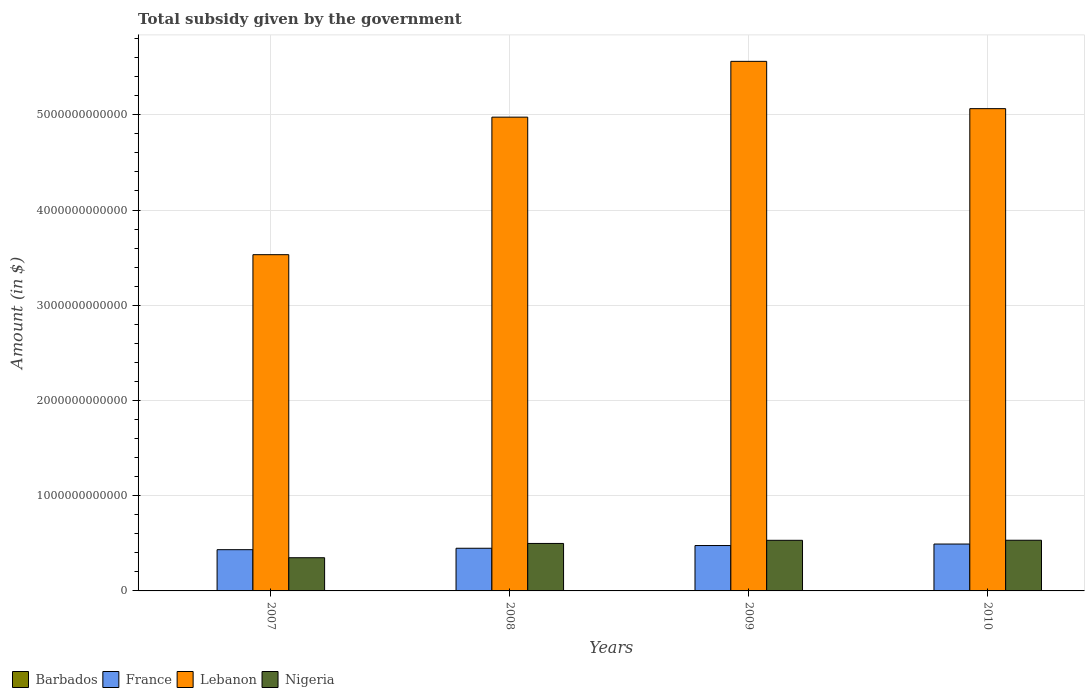How many different coloured bars are there?
Offer a very short reply. 4. Are the number of bars on each tick of the X-axis equal?
Your response must be concise. Yes. How many bars are there on the 3rd tick from the left?
Offer a terse response. 4. How many bars are there on the 2nd tick from the right?
Your response must be concise. 4. What is the total revenue collected by the government in Lebanon in 2009?
Your response must be concise. 5.56e+12. Across all years, what is the maximum total revenue collected by the government in France?
Your response must be concise. 4.92e+11. Across all years, what is the minimum total revenue collected by the government in Barbados?
Offer a very short reply. 1.14e+09. In which year was the total revenue collected by the government in Nigeria maximum?
Make the answer very short. 2010. In which year was the total revenue collected by the government in Barbados minimum?
Ensure brevity in your answer.  2007. What is the total total revenue collected by the government in Nigeria in the graph?
Provide a succinct answer. 1.91e+12. What is the difference between the total revenue collected by the government in France in 2007 and that in 2009?
Your response must be concise. -4.34e+1. What is the difference between the total revenue collected by the government in France in 2008 and the total revenue collected by the government in Nigeria in 2010?
Make the answer very short. -8.43e+1. What is the average total revenue collected by the government in Barbados per year?
Keep it short and to the point. 1.22e+09. In the year 2009, what is the difference between the total revenue collected by the government in France and total revenue collected by the government in Barbados?
Offer a terse response. 4.75e+11. In how many years, is the total revenue collected by the government in Barbados greater than 3800000000000 $?
Make the answer very short. 0. What is the ratio of the total revenue collected by the government in Nigeria in 2009 to that in 2010?
Ensure brevity in your answer.  1. What is the difference between the highest and the second highest total revenue collected by the government in Barbados?
Give a very brief answer. 1.23e+06. What is the difference between the highest and the lowest total revenue collected by the government in France?
Make the answer very short. 5.92e+1. In how many years, is the total revenue collected by the government in Barbados greater than the average total revenue collected by the government in Barbados taken over all years?
Keep it short and to the point. 3. Is the sum of the total revenue collected by the government in Nigeria in 2007 and 2008 greater than the maximum total revenue collected by the government in Lebanon across all years?
Provide a short and direct response. No. What does the 3rd bar from the left in 2010 represents?
Ensure brevity in your answer.  Lebanon. What does the 2nd bar from the right in 2009 represents?
Offer a very short reply. Lebanon. Is it the case that in every year, the sum of the total revenue collected by the government in France and total revenue collected by the government in Barbados is greater than the total revenue collected by the government in Nigeria?
Your answer should be compact. No. What is the difference between two consecutive major ticks on the Y-axis?
Offer a terse response. 1.00e+12. Are the values on the major ticks of Y-axis written in scientific E-notation?
Give a very brief answer. No. Where does the legend appear in the graph?
Offer a terse response. Bottom left. How many legend labels are there?
Make the answer very short. 4. How are the legend labels stacked?
Your response must be concise. Horizontal. What is the title of the graph?
Ensure brevity in your answer.  Total subsidy given by the government. Does "Latin America(all income levels)" appear as one of the legend labels in the graph?
Give a very brief answer. No. What is the label or title of the Y-axis?
Offer a terse response. Amount (in $). What is the Amount (in $) of Barbados in 2007?
Offer a terse response. 1.14e+09. What is the Amount (in $) of France in 2007?
Offer a very short reply. 4.33e+11. What is the Amount (in $) in Lebanon in 2007?
Your answer should be compact. 3.53e+12. What is the Amount (in $) in Nigeria in 2007?
Your answer should be compact. 3.49e+11. What is the Amount (in $) in Barbados in 2008?
Give a very brief answer. 1.25e+09. What is the Amount (in $) of France in 2008?
Offer a terse response. 4.48e+11. What is the Amount (in $) in Lebanon in 2008?
Your answer should be very brief. 4.98e+12. What is the Amount (in $) in Nigeria in 2008?
Give a very brief answer. 4.99e+11. What is the Amount (in $) of Barbados in 2009?
Keep it short and to the point. 1.23e+09. What is the Amount (in $) of France in 2009?
Offer a terse response. 4.77e+11. What is the Amount (in $) of Lebanon in 2009?
Offer a very short reply. 5.56e+12. What is the Amount (in $) in Nigeria in 2009?
Your answer should be compact. 5.32e+11. What is the Amount (in $) in Barbados in 2010?
Give a very brief answer. 1.25e+09. What is the Amount (in $) in France in 2010?
Provide a short and direct response. 4.92e+11. What is the Amount (in $) of Lebanon in 2010?
Your answer should be compact. 5.06e+12. What is the Amount (in $) in Nigeria in 2010?
Keep it short and to the point. 5.32e+11. Across all years, what is the maximum Amount (in $) of Barbados?
Provide a short and direct response. 1.25e+09. Across all years, what is the maximum Amount (in $) of France?
Give a very brief answer. 4.92e+11. Across all years, what is the maximum Amount (in $) in Lebanon?
Keep it short and to the point. 5.56e+12. Across all years, what is the maximum Amount (in $) in Nigeria?
Keep it short and to the point. 5.32e+11. Across all years, what is the minimum Amount (in $) in Barbados?
Give a very brief answer. 1.14e+09. Across all years, what is the minimum Amount (in $) of France?
Your response must be concise. 4.33e+11. Across all years, what is the minimum Amount (in $) in Lebanon?
Offer a very short reply. 3.53e+12. Across all years, what is the minimum Amount (in $) in Nigeria?
Provide a succinct answer. 3.49e+11. What is the total Amount (in $) in Barbados in the graph?
Ensure brevity in your answer.  4.87e+09. What is the total Amount (in $) of France in the graph?
Keep it short and to the point. 1.85e+12. What is the total Amount (in $) in Lebanon in the graph?
Offer a terse response. 1.91e+13. What is the total Amount (in $) in Nigeria in the graph?
Give a very brief answer. 1.91e+12. What is the difference between the Amount (in $) in Barbados in 2007 and that in 2008?
Keep it short and to the point. -1.06e+08. What is the difference between the Amount (in $) of France in 2007 and that in 2008?
Keep it short and to the point. -1.49e+1. What is the difference between the Amount (in $) of Lebanon in 2007 and that in 2008?
Give a very brief answer. -1.44e+12. What is the difference between the Amount (in $) of Nigeria in 2007 and that in 2008?
Keep it short and to the point. -1.50e+11. What is the difference between the Amount (in $) of Barbados in 2007 and that in 2009?
Your answer should be compact. -8.42e+07. What is the difference between the Amount (in $) in France in 2007 and that in 2009?
Give a very brief answer. -4.34e+1. What is the difference between the Amount (in $) in Lebanon in 2007 and that in 2009?
Give a very brief answer. -2.03e+12. What is the difference between the Amount (in $) in Nigeria in 2007 and that in 2009?
Provide a succinct answer. -1.83e+11. What is the difference between the Amount (in $) in Barbados in 2007 and that in 2010?
Make the answer very short. -1.07e+08. What is the difference between the Amount (in $) in France in 2007 and that in 2010?
Provide a succinct answer. -5.92e+1. What is the difference between the Amount (in $) of Lebanon in 2007 and that in 2010?
Provide a succinct answer. -1.53e+12. What is the difference between the Amount (in $) of Nigeria in 2007 and that in 2010?
Your answer should be compact. -1.84e+11. What is the difference between the Amount (in $) of Barbados in 2008 and that in 2009?
Your response must be concise. 2.16e+07. What is the difference between the Amount (in $) of France in 2008 and that in 2009?
Your answer should be compact. -2.86e+1. What is the difference between the Amount (in $) of Lebanon in 2008 and that in 2009?
Your answer should be very brief. -5.86e+11. What is the difference between the Amount (in $) of Nigeria in 2008 and that in 2009?
Provide a succinct answer. -3.30e+1. What is the difference between the Amount (in $) in Barbados in 2008 and that in 2010?
Keep it short and to the point. -1.23e+06. What is the difference between the Amount (in $) in France in 2008 and that in 2010?
Provide a succinct answer. -4.43e+1. What is the difference between the Amount (in $) in Lebanon in 2008 and that in 2010?
Give a very brief answer. -8.91e+1. What is the difference between the Amount (in $) of Nigeria in 2008 and that in 2010?
Your response must be concise. -3.37e+1. What is the difference between the Amount (in $) of Barbados in 2009 and that in 2010?
Provide a succinct answer. -2.28e+07. What is the difference between the Amount (in $) of France in 2009 and that in 2010?
Ensure brevity in your answer.  -1.57e+1. What is the difference between the Amount (in $) in Lebanon in 2009 and that in 2010?
Provide a short and direct response. 4.97e+11. What is the difference between the Amount (in $) of Nigeria in 2009 and that in 2010?
Your answer should be very brief. -7.00e+08. What is the difference between the Amount (in $) of Barbados in 2007 and the Amount (in $) of France in 2008?
Give a very brief answer. -4.47e+11. What is the difference between the Amount (in $) of Barbados in 2007 and the Amount (in $) of Lebanon in 2008?
Offer a terse response. -4.97e+12. What is the difference between the Amount (in $) in Barbados in 2007 and the Amount (in $) in Nigeria in 2008?
Ensure brevity in your answer.  -4.97e+11. What is the difference between the Amount (in $) in France in 2007 and the Amount (in $) in Lebanon in 2008?
Offer a very short reply. -4.54e+12. What is the difference between the Amount (in $) of France in 2007 and the Amount (in $) of Nigeria in 2008?
Offer a terse response. -6.55e+1. What is the difference between the Amount (in $) of Lebanon in 2007 and the Amount (in $) of Nigeria in 2008?
Keep it short and to the point. 3.03e+12. What is the difference between the Amount (in $) of Barbados in 2007 and the Amount (in $) of France in 2009?
Make the answer very short. -4.75e+11. What is the difference between the Amount (in $) of Barbados in 2007 and the Amount (in $) of Lebanon in 2009?
Your answer should be compact. -5.56e+12. What is the difference between the Amount (in $) of Barbados in 2007 and the Amount (in $) of Nigeria in 2009?
Provide a succinct answer. -5.30e+11. What is the difference between the Amount (in $) of France in 2007 and the Amount (in $) of Lebanon in 2009?
Provide a short and direct response. -5.13e+12. What is the difference between the Amount (in $) in France in 2007 and the Amount (in $) in Nigeria in 2009?
Offer a terse response. -9.85e+1. What is the difference between the Amount (in $) in Lebanon in 2007 and the Amount (in $) in Nigeria in 2009?
Your answer should be compact. 3.00e+12. What is the difference between the Amount (in $) in Barbados in 2007 and the Amount (in $) in France in 2010?
Ensure brevity in your answer.  -4.91e+11. What is the difference between the Amount (in $) in Barbados in 2007 and the Amount (in $) in Lebanon in 2010?
Provide a short and direct response. -5.06e+12. What is the difference between the Amount (in $) of Barbados in 2007 and the Amount (in $) of Nigeria in 2010?
Offer a terse response. -5.31e+11. What is the difference between the Amount (in $) of France in 2007 and the Amount (in $) of Lebanon in 2010?
Offer a terse response. -4.63e+12. What is the difference between the Amount (in $) in France in 2007 and the Amount (in $) in Nigeria in 2010?
Give a very brief answer. -9.92e+1. What is the difference between the Amount (in $) in Lebanon in 2007 and the Amount (in $) in Nigeria in 2010?
Keep it short and to the point. 3.00e+12. What is the difference between the Amount (in $) in Barbados in 2008 and the Amount (in $) in France in 2009?
Ensure brevity in your answer.  -4.75e+11. What is the difference between the Amount (in $) of Barbados in 2008 and the Amount (in $) of Lebanon in 2009?
Make the answer very short. -5.56e+12. What is the difference between the Amount (in $) in Barbados in 2008 and the Amount (in $) in Nigeria in 2009?
Your answer should be compact. -5.30e+11. What is the difference between the Amount (in $) of France in 2008 and the Amount (in $) of Lebanon in 2009?
Keep it short and to the point. -5.11e+12. What is the difference between the Amount (in $) in France in 2008 and the Amount (in $) in Nigeria in 2009?
Your answer should be compact. -8.36e+1. What is the difference between the Amount (in $) in Lebanon in 2008 and the Amount (in $) in Nigeria in 2009?
Your answer should be very brief. 4.44e+12. What is the difference between the Amount (in $) of Barbados in 2008 and the Amount (in $) of France in 2010?
Give a very brief answer. -4.91e+11. What is the difference between the Amount (in $) in Barbados in 2008 and the Amount (in $) in Lebanon in 2010?
Make the answer very short. -5.06e+12. What is the difference between the Amount (in $) in Barbados in 2008 and the Amount (in $) in Nigeria in 2010?
Keep it short and to the point. -5.31e+11. What is the difference between the Amount (in $) of France in 2008 and the Amount (in $) of Lebanon in 2010?
Keep it short and to the point. -4.62e+12. What is the difference between the Amount (in $) of France in 2008 and the Amount (in $) of Nigeria in 2010?
Your answer should be compact. -8.43e+1. What is the difference between the Amount (in $) of Lebanon in 2008 and the Amount (in $) of Nigeria in 2010?
Offer a very short reply. 4.44e+12. What is the difference between the Amount (in $) of Barbados in 2009 and the Amount (in $) of France in 2010?
Your answer should be very brief. -4.91e+11. What is the difference between the Amount (in $) in Barbados in 2009 and the Amount (in $) in Lebanon in 2010?
Your response must be concise. -5.06e+12. What is the difference between the Amount (in $) in Barbados in 2009 and the Amount (in $) in Nigeria in 2010?
Provide a short and direct response. -5.31e+11. What is the difference between the Amount (in $) in France in 2009 and the Amount (in $) in Lebanon in 2010?
Make the answer very short. -4.59e+12. What is the difference between the Amount (in $) in France in 2009 and the Amount (in $) in Nigeria in 2010?
Offer a very short reply. -5.57e+1. What is the difference between the Amount (in $) of Lebanon in 2009 and the Amount (in $) of Nigeria in 2010?
Offer a very short reply. 5.03e+12. What is the average Amount (in $) of Barbados per year?
Provide a short and direct response. 1.22e+09. What is the average Amount (in $) of France per year?
Provide a succinct answer. 4.63e+11. What is the average Amount (in $) in Lebanon per year?
Your response must be concise. 4.78e+12. What is the average Amount (in $) in Nigeria per year?
Ensure brevity in your answer.  4.78e+11. In the year 2007, what is the difference between the Amount (in $) of Barbados and Amount (in $) of France?
Offer a very short reply. -4.32e+11. In the year 2007, what is the difference between the Amount (in $) of Barbados and Amount (in $) of Lebanon?
Offer a very short reply. -3.53e+12. In the year 2007, what is the difference between the Amount (in $) of Barbados and Amount (in $) of Nigeria?
Provide a short and direct response. -3.47e+11. In the year 2007, what is the difference between the Amount (in $) in France and Amount (in $) in Lebanon?
Offer a very short reply. -3.10e+12. In the year 2007, what is the difference between the Amount (in $) of France and Amount (in $) of Nigeria?
Your response must be concise. 8.45e+1. In the year 2007, what is the difference between the Amount (in $) in Lebanon and Amount (in $) in Nigeria?
Offer a very short reply. 3.18e+12. In the year 2008, what is the difference between the Amount (in $) of Barbados and Amount (in $) of France?
Offer a very short reply. -4.47e+11. In the year 2008, what is the difference between the Amount (in $) of Barbados and Amount (in $) of Lebanon?
Provide a short and direct response. -4.97e+12. In the year 2008, what is the difference between the Amount (in $) in Barbados and Amount (in $) in Nigeria?
Make the answer very short. -4.97e+11. In the year 2008, what is the difference between the Amount (in $) in France and Amount (in $) in Lebanon?
Your answer should be very brief. -4.53e+12. In the year 2008, what is the difference between the Amount (in $) in France and Amount (in $) in Nigeria?
Keep it short and to the point. -5.06e+1. In the year 2008, what is the difference between the Amount (in $) in Lebanon and Amount (in $) in Nigeria?
Ensure brevity in your answer.  4.48e+12. In the year 2009, what is the difference between the Amount (in $) of Barbados and Amount (in $) of France?
Provide a succinct answer. -4.75e+11. In the year 2009, what is the difference between the Amount (in $) in Barbados and Amount (in $) in Lebanon?
Keep it short and to the point. -5.56e+12. In the year 2009, what is the difference between the Amount (in $) of Barbados and Amount (in $) of Nigeria?
Ensure brevity in your answer.  -5.30e+11. In the year 2009, what is the difference between the Amount (in $) in France and Amount (in $) in Lebanon?
Your answer should be very brief. -5.08e+12. In the year 2009, what is the difference between the Amount (in $) of France and Amount (in $) of Nigeria?
Keep it short and to the point. -5.50e+1. In the year 2009, what is the difference between the Amount (in $) in Lebanon and Amount (in $) in Nigeria?
Your response must be concise. 5.03e+12. In the year 2010, what is the difference between the Amount (in $) in Barbados and Amount (in $) in France?
Offer a terse response. -4.91e+11. In the year 2010, what is the difference between the Amount (in $) of Barbados and Amount (in $) of Lebanon?
Offer a terse response. -5.06e+12. In the year 2010, what is the difference between the Amount (in $) of Barbados and Amount (in $) of Nigeria?
Ensure brevity in your answer.  -5.31e+11. In the year 2010, what is the difference between the Amount (in $) in France and Amount (in $) in Lebanon?
Offer a terse response. -4.57e+12. In the year 2010, what is the difference between the Amount (in $) in France and Amount (in $) in Nigeria?
Make the answer very short. -4.00e+1. In the year 2010, what is the difference between the Amount (in $) of Lebanon and Amount (in $) of Nigeria?
Your answer should be very brief. 4.53e+12. What is the ratio of the Amount (in $) of Barbados in 2007 to that in 2008?
Provide a short and direct response. 0.92. What is the ratio of the Amount (in $) in France in 2007 to that in 2008?
Provide a short and direct response. 0.97. What is the ratio of the Amount (in $) in Lebanon in 2007 to that in 2008?
Offer a terse response. 0.71. What is the ratio of the Amount (in $) of Nigeria in 2007 to that in 2008?
Give a very brief answer. 0.7. What is the ratio of the Amount (in $) in Barbados in 2007 to that in 2009?
Provide a succinct answer. 0.93. What is the ratio of the Amount (in $) in France in 2007 to that in 2009?
Provide a short and direct response. 0.91. What is the ratio of the Amount (in $) in Lebanon in 2007 to that in 2009?
Give a very brief answer. 0.63. What is the ratio of the Amount (in $) in Nigeria in 2007 to that in 2009?
Your answer should be compact. 0.66. What is the ratio of the Amount (in $) of Barbados in 2007 to that in 2010?
Your answer should be compact. 0.91. What is the ratio of the Amount (in $) of France in 2007 to that in 2010?
Your answer should be compact. 0.88. What is the ratio of the Amount (in $) in Lebanon in 2007 to that in 2010?
Provide a short and direct response. 0.7. What is the ratio of the Amount (in $) of Nigeria in 2007 to that in 2010?
Make the answer very short. 0.65. What is the ratio of the Amount (in $) of Barbados in 2008 to that in 2009?
Provide a succinct answer. 1.02. What is the ratio of the Amount (in $) of France in 2008 to that in 2009?
Your answer should be compact. 0.94. What is the ratio of the Amount (in $) of Lebanon in 2008 to that in 2009?
Make the answer very short. 0.89. What is the ratio of the Amount (in $) in Nigeria in 2008 to that in 2009?
Offer a very short reply. 0.94. What is the ratio of the Amount (in $) in Barbados in 2008 to that in 2010?
Offer a very short reply. 1. What is the ratio of the Amount (in $) of France in 2008 to that in 2010?
Offer a very short reply. 0.91. What is the ratio of the Amount (in $) in Lebanon in 2008 to that in 2010?
Your answer should be compact. 0.98. What is the ratio of the Amount (in $) of Nigeria in 2008 to that in 2010?
Your answer should be compact. 0.94. What is the ratio of the Amount (in $) in Barbados in 2009 to that in 2010?
Your answer should be very brief. 0.98. What is the ratio of the Amount (in $) of Lebanon in 2009 to that in 2010?
Offer a very short reply. 1.1. What is the ratio of the Amount (in $) of Nigeria in 2009 to that in 2010?
Offer a terse response. 1. What is the difference between the highest and the second highest Amount (in $) in Barbados?
Give a very brief answer. 1.23e+06. What is the difference between the highest and the second highest Amount (in $) in France?
Ensure brevity in your answer.  1.57e+1. What is the difference between the highest and the second highest Amount (in $) in Lebanon?
Your response must be concise. 4.97e+11. What is the difference between the highest and the second highest Amount (in $) in Nigeria?
Offer a terse response. 7.00e+08. What is the difference between the highest and the lowest Amount (in $) of Barbados?
Keep it short and to the point. 1.07e+08. What is the difference between the highest and the lowest Amount (in $) of France?
Keep it short and to the point. 5.92e+1. What is the difference between the highest and the lowest Amount (in $) in Lebanon?
Offer a very short reply. 2.03e+12. What is the difference between the highest and the lowest Amount (in $) of Nigeria?
Your response must be concise. 1.84e+11. 